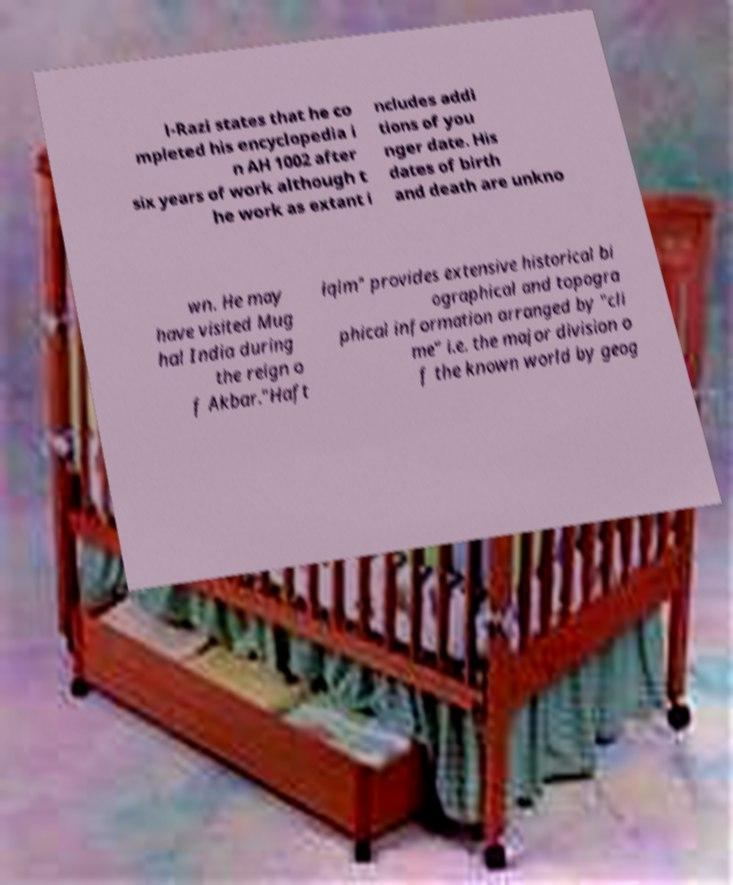For documentation purposes, I need the text within this image transcribed. Could you provide that? l-Razi states that he co mpleted his encyclopedia i n AH 1002 after six years of work although t he work as extant i ncludes addi tions of you nger date. His dates of birth and death are unkno wn. He may have visited Mug hal India during the reign o f Akbar."Haft iqlm" provides extensive historical bi ographical and topogra phical information arranged by "cli me" i.e. the major division o f the known world by geog 